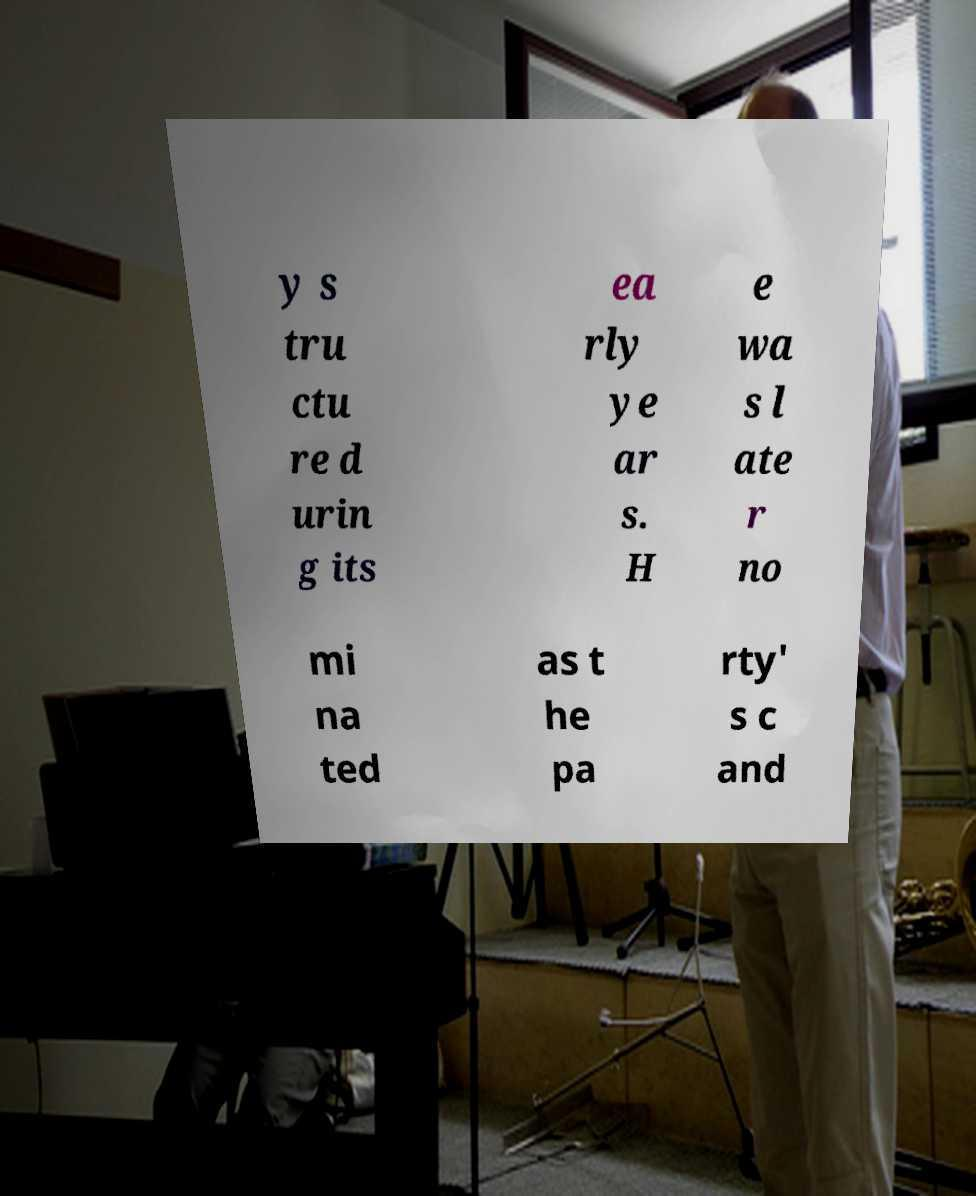Can you read and provide the text displayed in the image?This photo seems to have some interesting text. Can you extract and type it out for me? y s tru ctu re d urin g its ea rly ye ar s. H e wa s l ate r no mi na ted as t he pa rty' s c and 